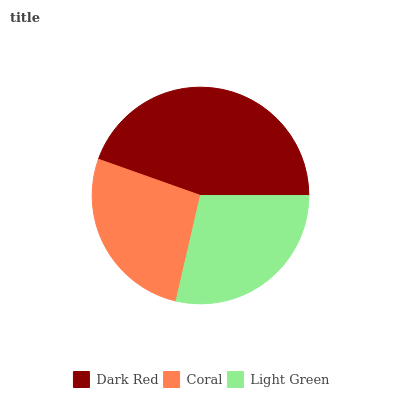Is Coral the minimum?
Answer yes or no. Yes. Is Dark Red the maximum?
Answer yes or no. Yes. Is Light Green the minimum?
Answer yes or no. No. Is Light Green the maximum?
Answer yes or no. No. Is Light Green greater than Coral?
Answer yes or no. Yes. Is Coral less than Light Green?
Answer yes or no. Yes. Is Coral greater than Light Green?
Answer yes or no. No. Is Light Green less than Coral?
Answer yes or no. No. Is Light Green the high median?
Answer yes or no. Yes. Is Light Green the low median?
Answer yes or no. Yes. Is Coral the high median?
Answer yes or no. No. Is Dark Red the low median?
Answer yes or no. No. 